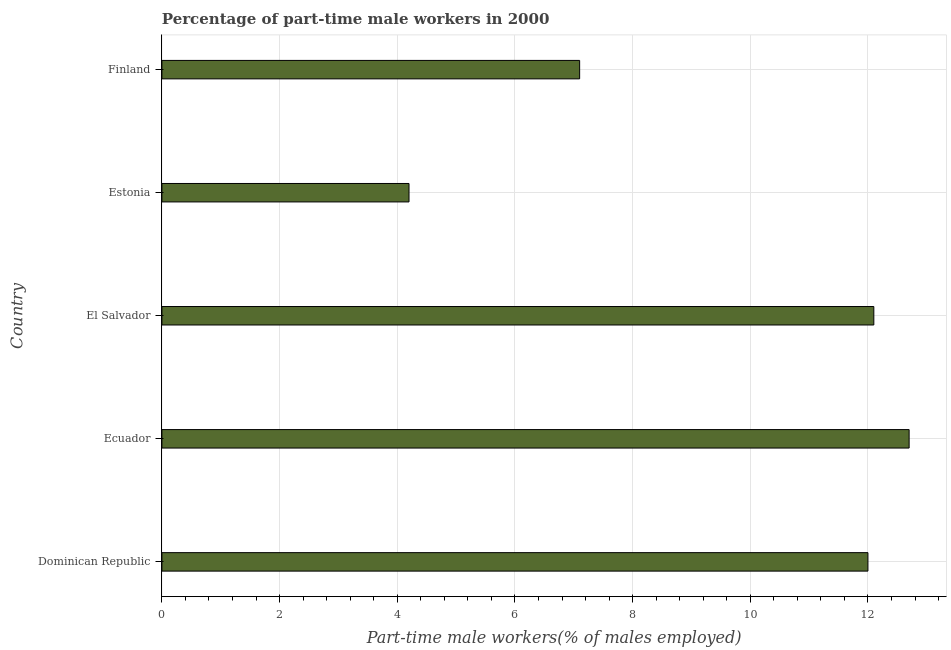What is the title of the graph?
Offer a terse response. Percentage of part-time male workers in 2000. What is the label or title of the X-axis?
Offer a terse response. Part-time male workers(% of males employed). What is the percentage of part-time male workers in Finland?
Offer a terse response. 7.1. Across all countries, what is the maximum percentage of part-time male workers?
Your response must be concise. 12.7. Across all countries, what is the minimum percentage of part-time male workers?
Offer a terse response. 4.2. In which country was the percentage of part-time male workers maximum?
Your answer should be very brief. Ecuador. In which country was the percentage of part-time male workers minimum?
Your answer should be compact. Estonia. What is the sum of the percentage of part-time male workers?
Provide a short and direct response. 48.1. What is the difference between the percentage of part-time male workers in Dominican Republic and El Salvador?
Your answer should be very brief. -0.1. What is the average percentage of part-time male workers per country?
Offer a very short reply. 9.62. What is the ratio of the percentage of part-time male workers in El Salvador to that in Finland?
Make the answer very short. 1.7. Is the percentage of part-time male workers in Ecuador less than that in Estonia?
Your response must be concise. No. What is the difference between the highest and the second highest percentage of part-time male workers?
Your response must be concise. 0.6. Is the sum of the percentage of part-time male workers in Estonia and Finland greater than the maximum percentage of part-time male workers across all countries?
Provide a short and direct response. No. Are all the bars in the graph horizontal?
Offer a terse response. Yes. How many countries are there in the graph?
Provide a succinct answer. 5. Are the values on the major ticks of X-axis written in scientific E-notation?
Your answer should be compact. No. What is the Part-time male workers(% of males employed) in Dominican Republic?
Offer a terse response. 12. What is the Part-time male workers(% of males employed) in Ecuador?
Provide a short and direct response. 12.7. What is the Part-time male workers(% of males employed) of El Salvador?
Your answer should be compact. 12.1. What is the Part-time male workers(% of males employed) of Estonia?
Provide a short and direct response. 4.2. What is the Part-time male workers(% of males employed) in Finland?
Make the answer very short. 7.1. What is the difference between the Part-time male workers(% of males employed) in Dominican Republic and Ecuador?
Offer a terse response. -0.7. What is the difference between the Part-time male workers(% of males employed) in Dominican Republic and Estonia?
Keep it short and to the point. 7.8. What is the difference between the Part-time male workers(% of males employed) in Ecuador and Finland?
Your answer should be compact. 5.6. What is the difference between the Part-time male workers(% of males employed) in El Salvador and Finland?
Your answer should be very brief. 5. What is the difference between the Part-time male workers(% of males employed) in Estonia and Finland?
Make the answer very short. -2.9. What is the ratio of the Part-time male workers(% of males employed) in Dominican Republic to that in Ecuador?
Provide a succinct answer. 0.94. What is the ratio of the Part-time male workers(% of males employed) in Dominican Republic to that in Estonia?
Provide a short and direct response. 2.86. What is the ratio of the Part-time male workers(% of males employed) in Dominican Republic to that in Finland?
Your answer should be very brief. 1.69. What is the ratio of the Part-time male workers(% of males employed) in Ecuador to that in El Salvador?
Provide a short and direct response. 1.05. What is the ratio of the Part-time male workers(% of males employed) in Ecuador to that in Estonia?
Offer a terse response. 3.02. What is the ratio of the Part-time male workers(% of males employed) in Ecuador to that in Finland?
Provide a short and direct response. 1.79. What is the ratio of the Part-time male workers(% of males employed) in El Salvador to that in Estonia?
Your answer should be very brief. 2.88. What is the ratio of the Part-time male workers(% of males employed) in El Salvador to that in Finland?
Offer a terse response. 1.7. What is the ratio of the Part-time male workers(% of males employed) in Estonia to that in Finland?
Provide a succinct answer. 0.59. 